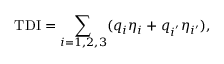Convert formula to latex. <formula><loc_0><loc_0><loc_500><loc_500>T D I = \sum _ { i = 1 , 2 , 3 } ( q _ { i } \eta _ { i } + q _ { i ^ { ^ { \prime } } } \eta _ { i ^ { \prime } } ) ,</formula> 